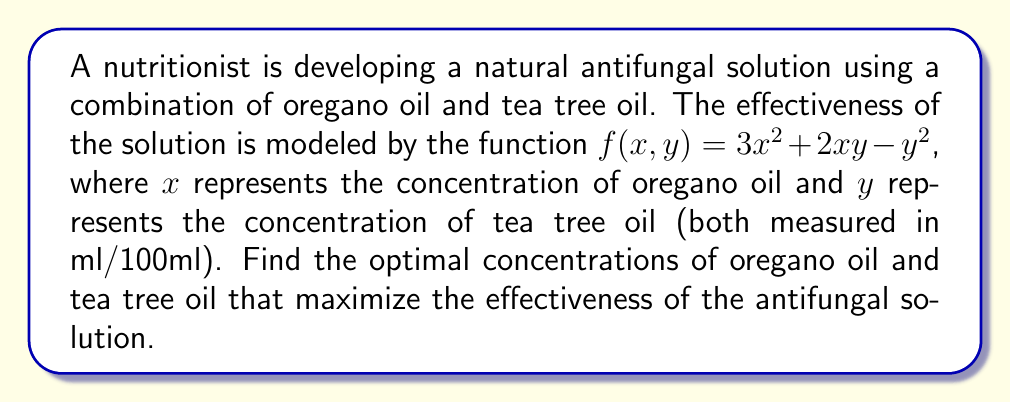Solve this math problem. To find the optimal concentrations, we need to find the critical points of the function $f(x, y)$ and determine which one maximizes the effectiveness.

Step 1: Calculate the partial derivatives of $f(x, y)$:
$$\frac{\partial f}{\partial x} = 6x + 2y$$
$$\frac{\partial f}{\partial y} = 2x - 2y$$

Step 2: Set both partial derivatives to zero and solve the system of equations:
$$6x + 2y = 0 \quad (1)$$
$$2x - 2y = 0 \quad (2)$$

Step 3: From equation (2), we can deduce that $x = y$.
Substituting this into equation (1):
$$6x + 2x = 0$$
$$8x = 0$$
$$x = 0$$

Since $x = y$, we also have $y = 0$.

Step 4: To confirm this critical point is a maximum, we can calculate the Hessian matrix:
$$H = \begin{bmatrix} 
6 & 2 \\
2 & -2
\end{bmatrix}$$

The determinant of $H$ is $-16$, which is negative, indicating a saddle point at $(0, 0)$.

Step 5: Since $(0, 0)$ is not a maximum, we need to investigate the behavior of $f(x, y)$ as $x$ and $y$ approach infinity. As $x$ increases, the $3x^2$ term dominates, causing $f(x, y)$ to increase without bound. This suggests that the maximum effectiveness occurs at the highest possible concentrations of both oils.

However, in practice, there would be upper limits on the concentrations due to safety concerns and solubility issues. Let's assume the maximum concentration for each oil is 5 ml/100ml.

Step 6: Evaluate $f(x, y)$ at the corners of the feasible region:
$f(0, 0) = 0$
$f(5, 0) = 75$
$f(0, 5) = -25$
$f(5, 5) = 100$

The maximum value occurs at $(5, 5)$, corresponding to the highest allowable concentrations of both oils.
Answer: Oregano oil: 5 ml/100ml, Tea tree oil: 5 ml/100ml 